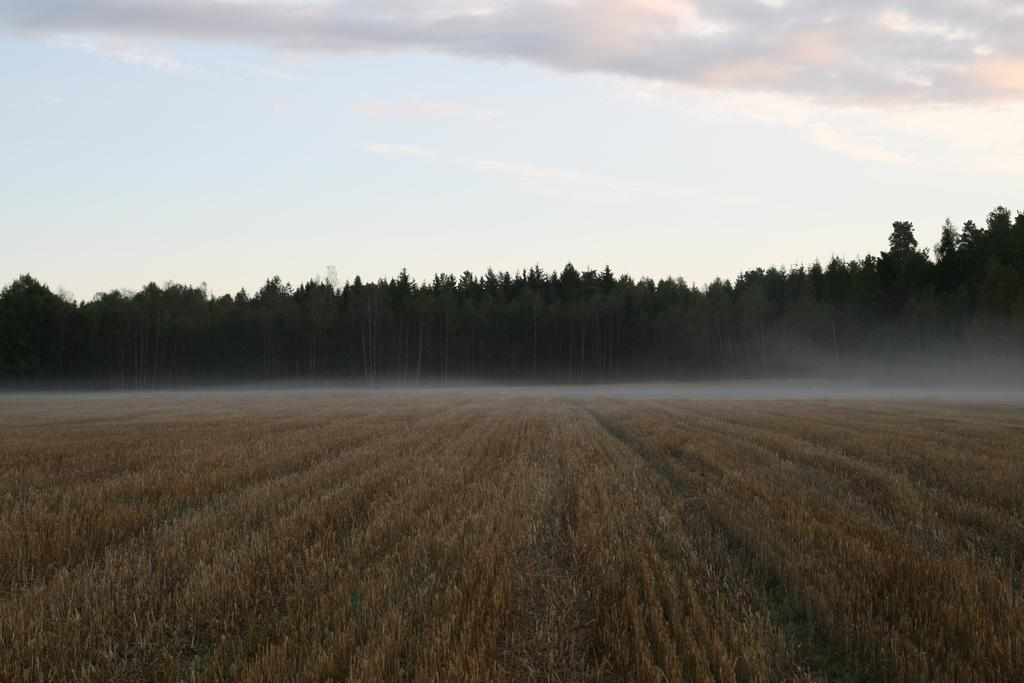What type of vegetation is visible in the front of the image? There is dry grass in the front of the image. What can be seen in the background of the image? There are trees in the background of the image. How would you describe the sky in the image? The sky is cloudy in the image. Where is the cup placed in the image? There is no cup present in the image. Can you describe the sheet used to cover the trees in the image? There is no sheet covering the trees in the image; the trees are visible in the background. 